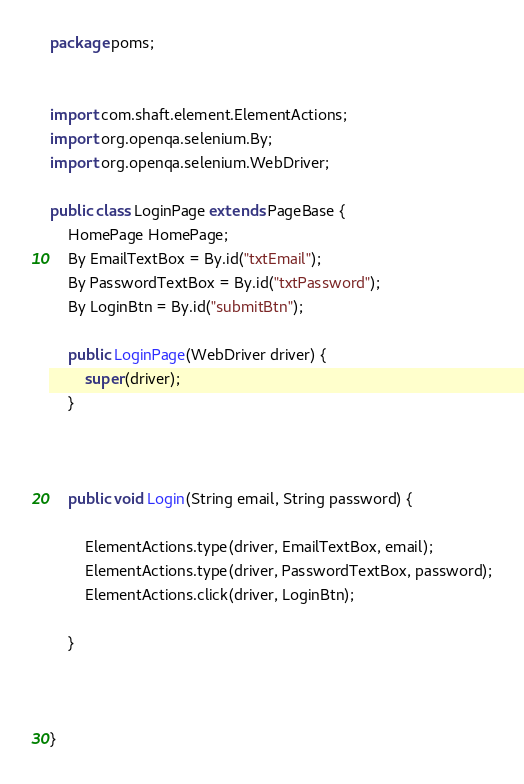<code> <loc_0><loc_0><loc_500><loc_500><_Java_>package poms;


import com.shaft.element.ElementActions;
import org.openqa.selenium.By;
import org.openqa.selenium.WebDriver;

public class LoginPage extends PageBase {
    HomePage HomePage;
    By EmailTextBox = By.id("txtEmail");
    By PasswordTextBox = By.id("txtPassword");
    By LoginBtn = By.id("submitBtn");

    public LoginPage(WebDriver driver) {
        super(driver);
    }



    public void Login(String email, String password) {

        ElementActions.type(driver, EmailTextBox, email);
        ElementActions.type(driver, PasswordTextBox, password);
        ElementActions.click(driver, LoginBtn);

    }



}
</code> 